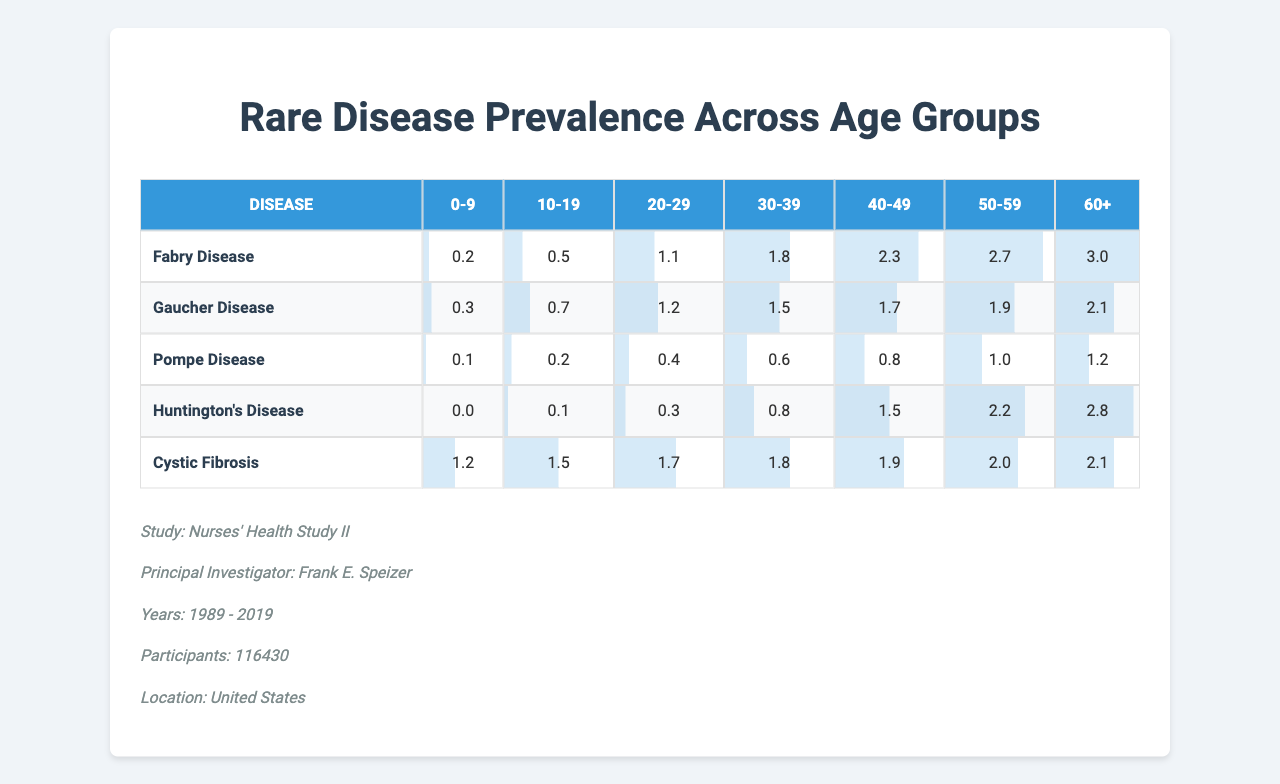What is the prevalence of Fabry Disease in the age group 30-39? According to the table, Fabry Disease has a prevalence of 1.8 in the 30-39 age group.
Answer: 1.8 Which disease has the highest prevalence in the age group 60+? In the table, Cystic Fibrosis has a prevalence of 2.1 in the 60+ age group, which is the highest compared to other diseases.
Answer: Cystic Fibrosis What is the average prevalence of Gaucher Disease across all age groups? The sum of the prevalences for Gaucher Disease is 0.3 + 0.7 + 1.2 + 1.5 + 1.7 + 1.9 + 2.1 = 9.4. There are 7 age groups, so the average prevalence is 9.4 / 7 = 1.34.
Answer: 1.34 Is the prevalence of Pompe Disease higher than 1 in the 50-59 age group? The table shows that the prevalence of Pompe Disease in the 50-59 age group is 1.0, which is not higher than 1.
Answer: No Which disease shows the greatest increase in prevalence from age group 0-9 to age group 60+? For Fabry Disease, the prevalence increases from 0.2 to 3.0, a change of 2.8. For Gaucher Disease, it increases from 0.3 to 2.1 (1.8 increase). For Pompe Disease, the increase is from 0.1 to 1.2 (1.1 increase). For Huntington's Disease, it's from 0.0 to 2.8 (2.8 increase). For Cystic Fibrosis, it increases from 1.2 to 2.1 (0.9 increase). The greatest increase of 2.8 is for both Fabry and Huntington's Disease.
Answer: Fabry and Huntington's Disease What is the total prevalence of Cystic Fibrosis across all age groups? The total prevalence of Cystic Fibrosis is calculated as 1.2 + 1.5 + 1.7 + 1.8 + 1.9 + 2.0 + 2.1 = 12.2.
Answer: 12.2 Is the prevalence of Huntington's Disease greater than the prevalence of Pompe Disease in the 40-49 age group? In the 40-49 age group, Huntington's Disease has a prevalence of 1.5 while Pompe Disease has a prevalence of 0.8, therefore, Huntington's is greater.
Answer: Yes What is the difference in prevalence between Fabry Disease and Huntington's Disease in the age group 50-59? The prevalence for Fabry Disease in this age group is 2.7, and for Huntington's Disease, it is 2.2. The difference is 2.7 - 2.2 = 0.5.
Answer: 0.5 Which disease has a prevalence of 0.0 in the age group 0-9? The table indicates that Huntington's Disease has a prevalence of 0.0 in the age group 0-9.
Answer: Huntington's Disease What is the median prevalence of Gaucher Disease between the age groups 10-19 and 20-29? The prevalence values for Gaucher Disease in these age groups are 0.7 and 1.2, respectively. To find the median, we average the two values: (0.7 + 1.2) / 2 = 0.95.
Answer: 0.95 Which age group sees the highest prevalence for Pompe Disease? In the table, the highest prevalence for Pompe Disease is 1.2 in the 60+ age group.
Answer: 60+ 